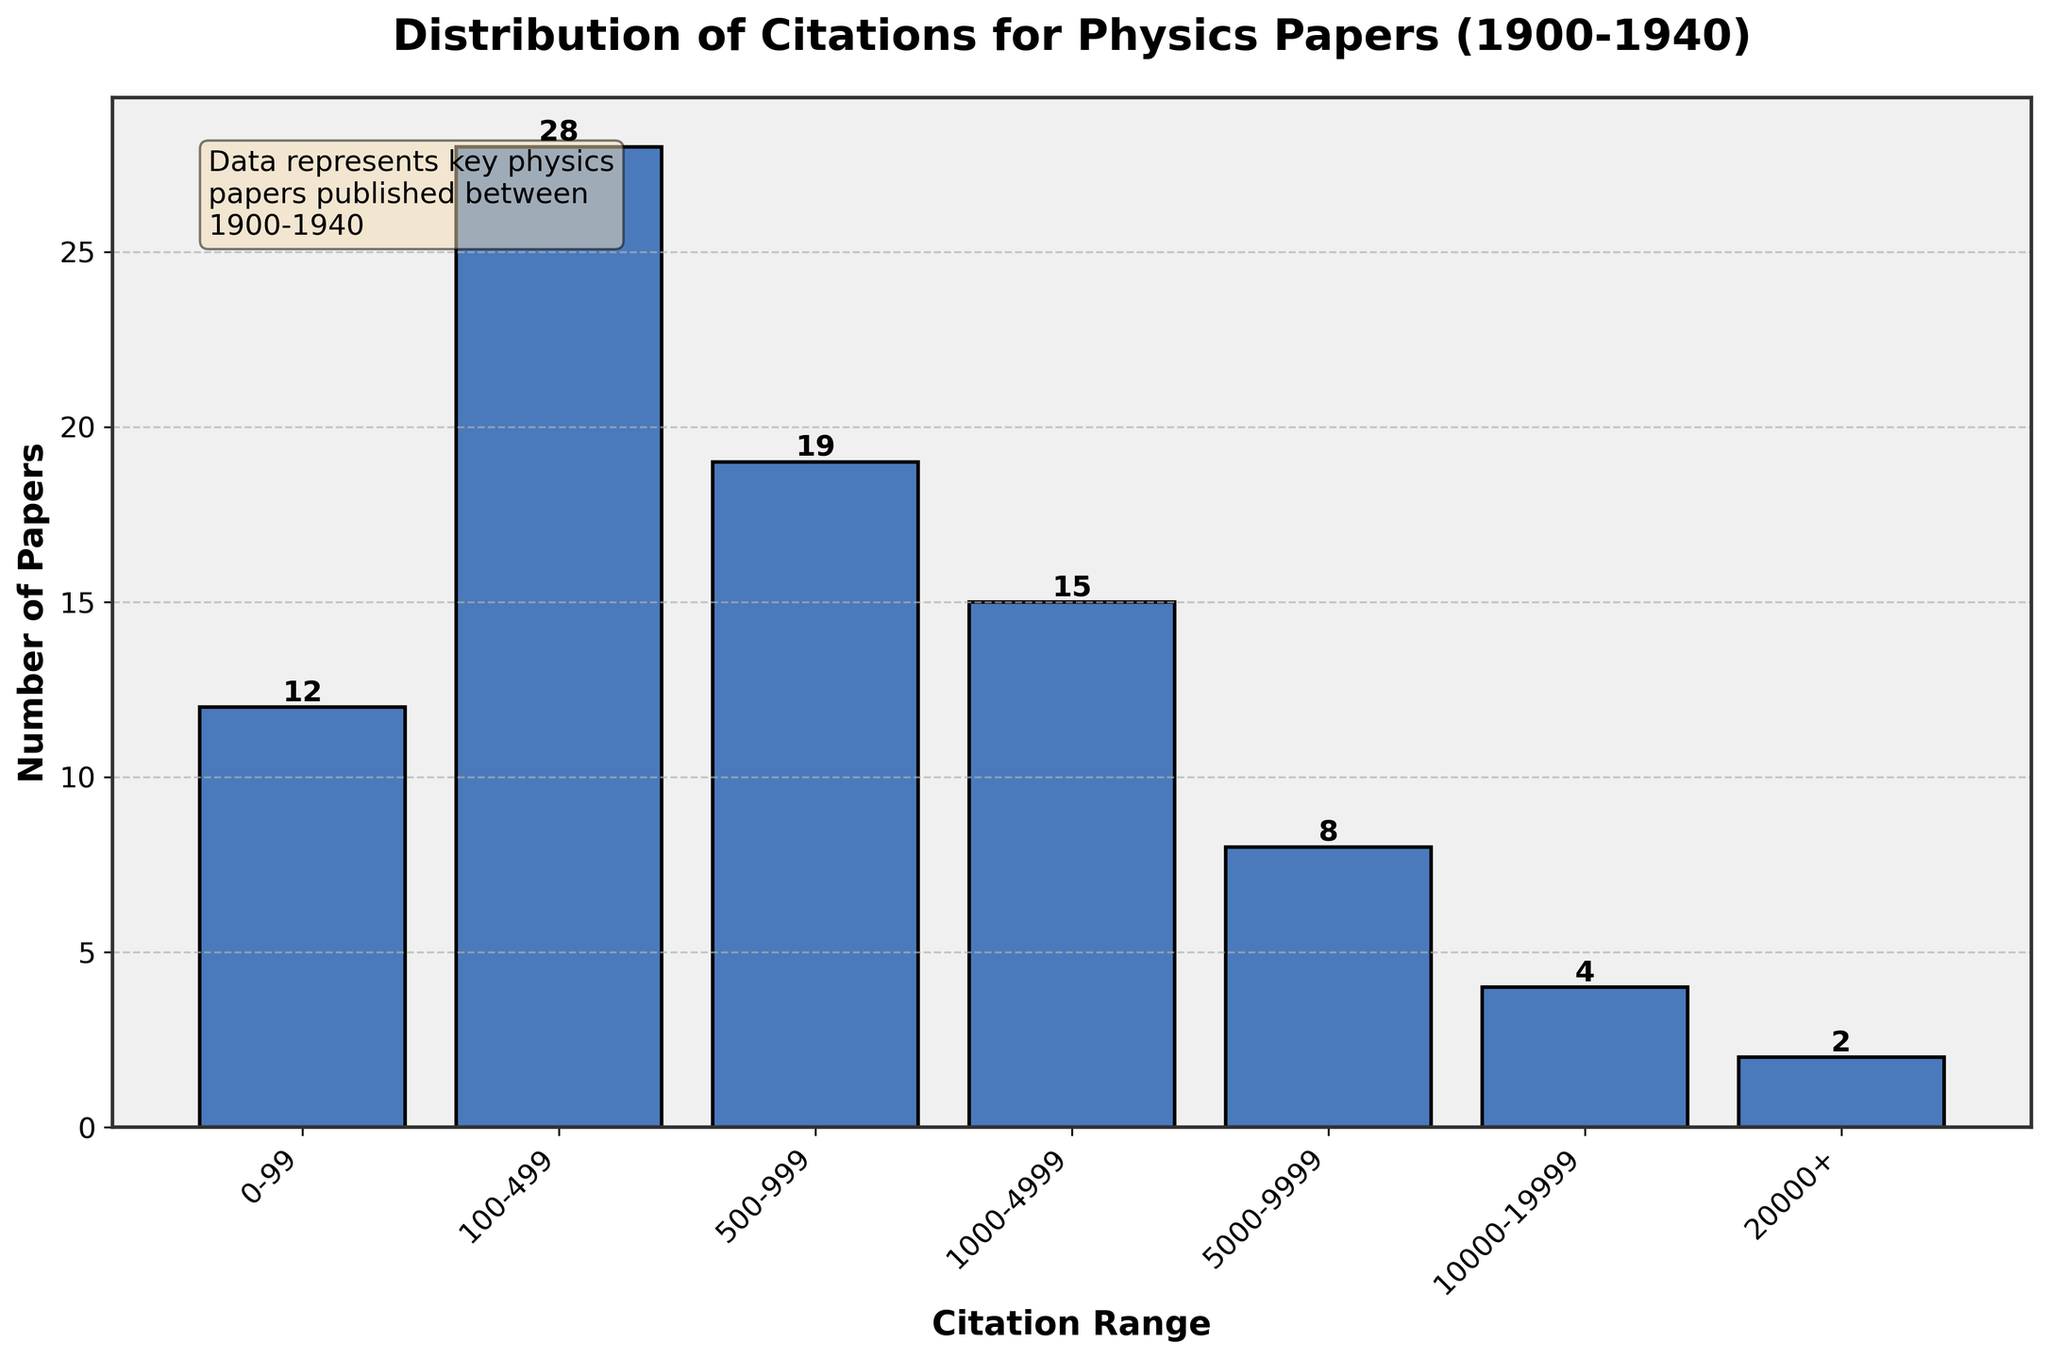What is the title of the histogram? The title is usually found at the top of the histogram. It summarizes what the data represents.
Answer: Distribution of Citations for Physics Papers (1900-1940) How many citation ranges are there in the histogram? By counting the distinct bars or categories on the x-axis, one can determine the number of citation ranges.
Answer: 7 Which citation range has the highest number of papers? By comparing the heights of the bars, the citation range with the tallest bar represents the highest count.
Answer: 100-499 How many papers received between 5000 and 9999 citations? By identifying the bar corresponding to the 5000-9999 range and reading the label above it, we get the count.
Answer: 8 What's the total number of papers listed in the histogram? Add up the values of all the bars. (12 + 28 + 19 + 15 + 8 + 4 + 2 = 88)
Answer: 88 What is the difference in the number of papers between the ranges 100-499 and 500-999? Subtract the number of papers in 500-999 from 100-499. (28 - 19)
Answer: 9 Which citation range has the fewest number of papers? The bar with the shortest height indicates the citation range with the fewest papers.
Answer: 20000+ Did more papers receive between 0-99 citations or between 1000-4999 citations? Compare the heights or the numbers above the bars for the ranges 0-99 and 1000-4999.
Answer: 1000-4999 What percentage of the total papers received between 1000-4999 citations? Calculate `(number of papers in the range / total number of papers) * 100`. (15 / 88) * 100 ≈ 17.05%
Answer: 17.05% What is the average number of papers per citation range? Calculate the total number of papers divided by the number of citation ranges. (88 / 7 ≈ 12.57)
Answer: 12.57 